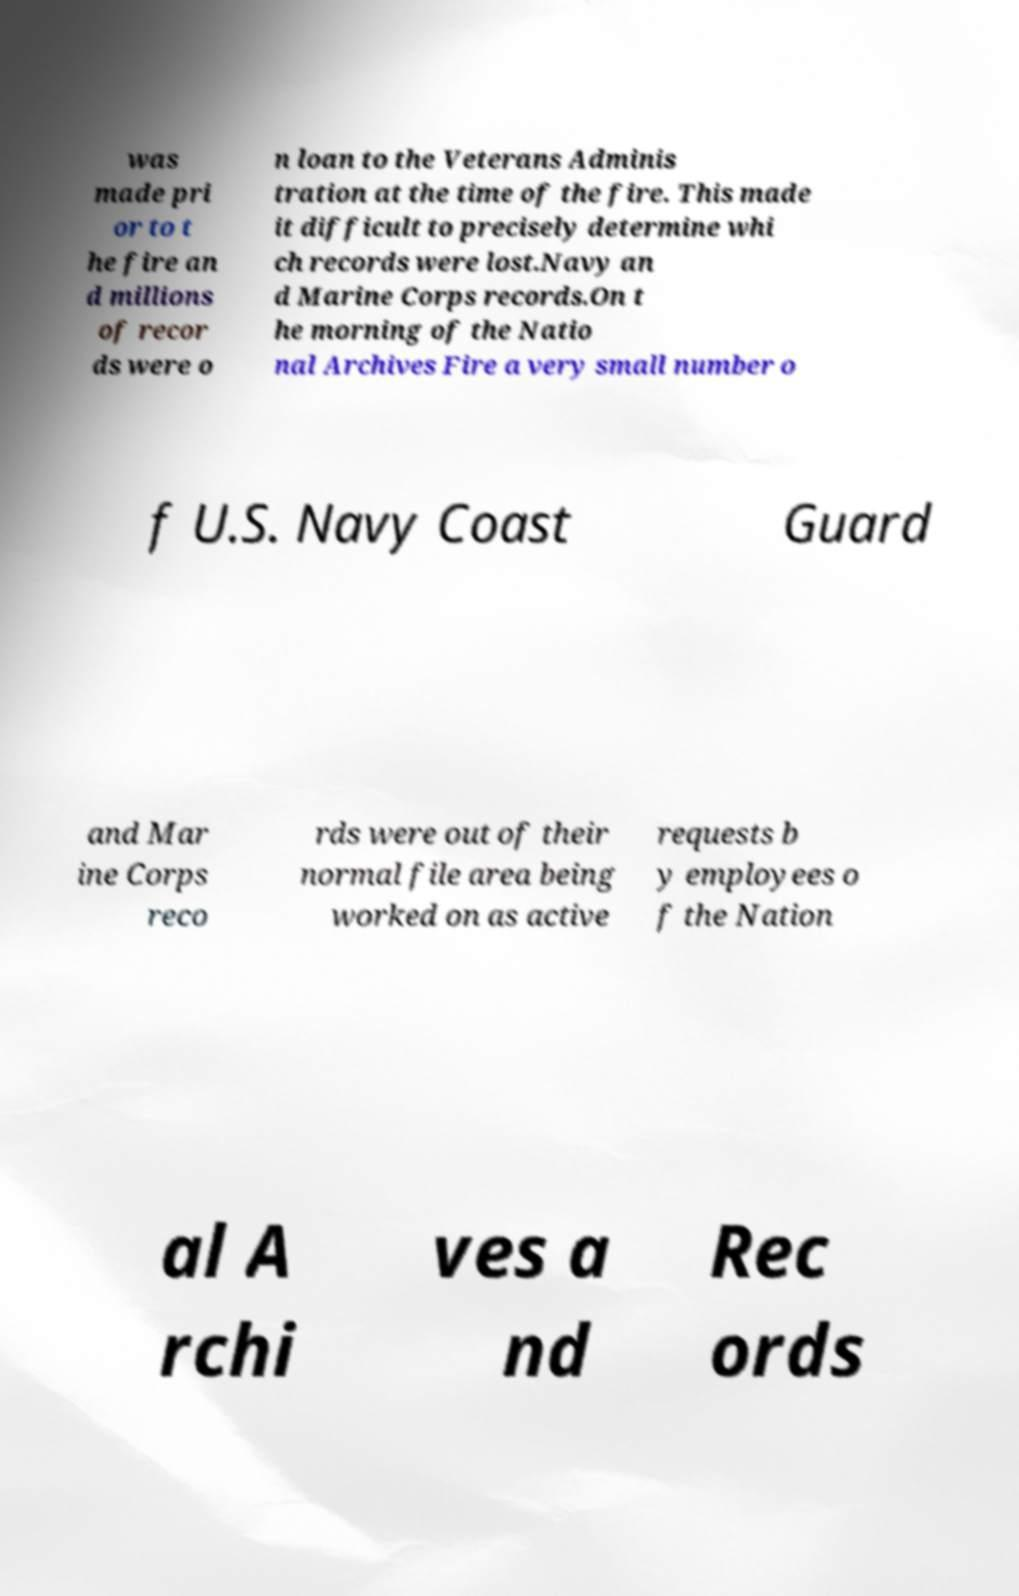There's text embedded in this image that I need extracted. Can you transcribe it verbatim? was made pri or to t he fire an d millions of recor ds were o n loan to the Veterans Adminis tration at the time of the fire. This made it difficult to precisely determine whi ch records were lost.Navy an d Marine Corps records.On t he morning of the Natio nal Archives Fire a very small number o f U.S. Navy Coast Guard and Mar ine Corps reco rds were out of their normal file area being worked on as active requests b y employees o f the Nation al A rchi ves a nd Rec ords 